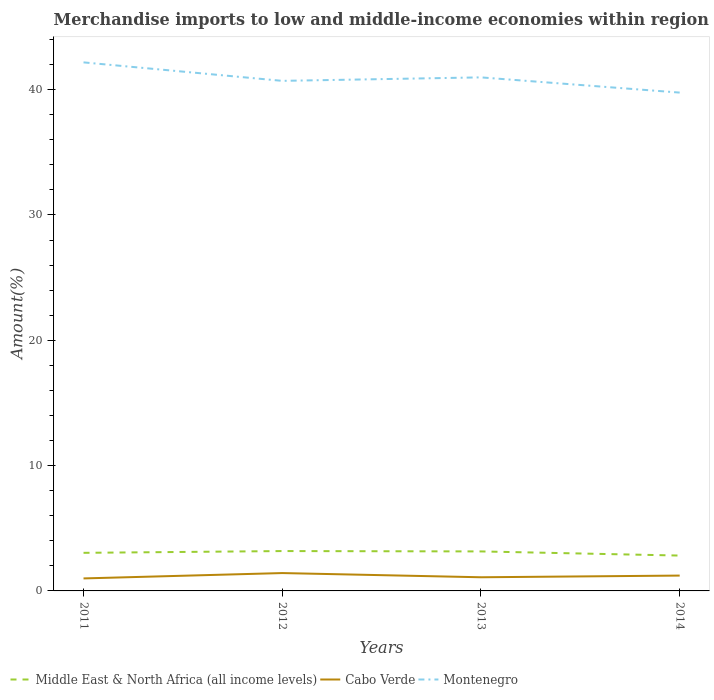Does the line corresponding to Middle East & North Africa (all income levels) intersect with the line corresponding to Montenegro?
Provide a short and direct response. No. Is the number of lines equal to the number of legend labels?
Your answer should be compact. Yes. Across all years, what is the maximum percentage of amount earned from merchandise imports in Cabo Verde?
Your answer should be compact. 1. In which year was the percentage of amount earned from merchandise imports in Montenegro maximum?
Provide a short and direct response. 2014. What is the total percentage of amount earned from merchandise imports in Montenegro in the graph?
Your answer should be compact. 1.47. What is the difference between the highest and the second highest percentage of amount earned from merchandise imports in Cabo Verde?
Offer a terse response. 0.43. How many lines are there?
Give a very brief answer. 3. How many years are there in the graph?
Make the answer very short. 4. Are the values on the major ticks of Y-axis written in scientific E-notation?
Make the answer very short. No. Does the graph contain any zero values?
Ensure brevity in your answer.  No. How many legend labels are there?
Give a very brief answer. 3. What is the title of the graph?
Offer a terse response. Merchandise imports to low and middle-income economies within region. Does "Barbados" appear as one of the legend labels in the graph?
Your answer should be compact. No. What is the label or title of the X-axis?
Provide a short and direct response. Years. What is the label or title of the Y-axis?
Provide a short and direct response. Amount(%). What is the Amount(%) in Middle East & North Africa (all income levels) in 2011?
Ensure brevity in your answer.  3.04. What is the Amount(%) in Cabo Verde in 2011?
Provide a succinct answer. 1. What is the Amount(%) in Montenegro in 2011?
Make the answer very short. 42.17. What is the Amount(%) of Middle East & North Africa (all income levels) in 2012?
Give a very brief answer. 3.18. What is the Amount(%) of Cabo Verde in 2012?
Make the answer very short. 1.43. What is the Amount(%) in Montenegro in 2012?
Your answer should be very brief. 40.7. What is the Amount(%) of Middle East & North Africa (all income levels) in 2013?
Your answer should be compact. 3.15. What is the Amount(%) of Cabo Verde in 2013?
Keep it short and to the point. 1.09. What is the Amount(%) of Montenegro in 2013?
Your answer should be compact. 40.98. What is the Amount(%) in Middle East & North Africa (all income levels) in 2014?
Your response must be concise. 2.82. What is the Amount(%) of Cabo Verde in 2014?
Provide a short and direct response. 1.22. What is the Amount(%) of Montenegro in 2014?
Your answer should be compact. 39.76. Across all years, what is the maximum Amount(%) of Middle East & North Africa (all income levels)?
Make the answer very short. 3.18. Across all years, what is the maximum Amount(%) of Cabo Verde?
Ensure brevity in your answer.  1.43. Across all years, what is the maximum Amount(%) in Montenegro?
Your answer should be compact. 42.17. Across all years, what is the minimum Amount(%) of Middle East & North Africa (all income levels)?
Make the answer very short. 2.82. Across all years, what is the minimum Amount(%) of Cabo Verde?
Your answer should be compact. 1. Across all years, what is the minimum Amount(%) of Montenegro?
Make the answer very short. 39.76. What is the total Amount(%) in Middle East & North Africa (all income levels) in the graph?
Provide a succinct answer. 12.19. What is the total Amount(%) of Cabo Verde in the graph?
Keep it short and to the point. 4.74. What is the total Amount(%) in Montenegro in the graph?
Provide a succinct answer. 163.61. What is the difference between the Amount(%) of Middle East & North Africa (all income levels) in 2011 and that in 2012?
Your answer should be very brief. -0.14. What is the difference between the Amount(%) of Cabo Verde in 2011 and that in 2012?
Provide a short and direct response. -0.43. What is the difference between the Amount(%) in Montenegro in 2011 and that in 2012?
Your response must be concise. 1.47. What is the difference between the Amount(%) in Middle East & North Africa (all income levels) in 2011 and that in 2013?
Offer a very short reply. -0.11. What is the difference between the Amount(%) in Cabo Verde in 2011 and that in 2013?
Your response must be concise. -0.09. What is the difference between the Amount(%) in Montenegro in 2011 and that in 2013?
Make the answer very short. 1.2. What is the difference between the Amount(%) of Middle East & North Africa (all income levels) in 2011 and that in 2014?
Your answer should be very brief. 0.22. What is the difference between the Amount(%) of Cabo Verde in 2011 and that in 2014?
Provide a succinct answer. -0.23. What is the difference between the Amount(%) of Montenegro in 2011 and that in 2014?
Ensure brevity in your answer.  2.41. What is the difference between the Amount(%) in Middle East & North Africa (all income levels) in 2012 and that in 2013?
Ensure brevity in your answer.  0.03. What is the difference between the Amount(%) of Cabo Verde in 2012 and that in 2013?
Keep it short and to the point. 0.34. What is the difference between the Amount(%) in Montenegro in 2012 and that in 2013?
Offer a terse response. -0.28. What is the difference between the Amount(%) in Middle East & North Africa (all income levels) in 2012 and that in 2014?
Provide a short and direct response. 0.36. What is the difference between the Amount(%) in Cabo Verde in 2012 and that in 2014?
Your response must be concise. 0.2. What is the difference between the Amount(%) in Montenegro in 2012 and that in 2014?
Keep it short and to the point. 0.94. What is the difference between the Amount(%) in Middle East & North Africa (all income levels) in 2013 and that in 2014?
Provide a short and direct response. 0.33. What is the difference between the Amount(%) of Cabo Verde in 2013 and that in 2014?
Your answer should be very brief. -0.13. What is the difference between the Amount(%) of Montenegro in 2013 and that in 2014?
Your answer should be compact. 1.21. What is the difference between the Amount(%) in Middle East & North Africa (all income levels) in 2011 and the Amount(%) in Cabo Verde in 2012?
Give a very brief answer. 1.61. What is the difference between the Amount(%) in Middle East & North Africa (all income levels) in 2011 and the Amount(%) in Montenegro in 2012?
Keep it short and to the point. -37.66. What is the difference between the Amount(%) of Cabo Verde in 2011 and the Amount(%) of Montenegro in 2012?
Provide a short and direct response. -39.7. What is the difference between the Amount(%) of Middle East & North Africa (all income levels) in 2011 and the Amount(%) of Cabo Verde in 2013?
Give a very brief answer. 1.95. What is the difference between the Amount(%) in Middle East & North Africa (all income levels) in 2011 and the Amount(%) in Montenegro in 2013?
Make the answer very short. -37.94. What is the difference between the Amount(%) in Cabo Verde in 2011 and the Amount(%) in Montenegro in 2013?
Your answer should be compact. -39.98. What is the difference between the Amount(%) in Middle East & North Africa (all income levels) in 2011 and the Amount(%) in Cabo Verde in 2014?
Ensure brevity in your answer.  1.81. What is the difference between the Amount(%) in Middle East & North Africa (all income levels) in 2011 and the Amount(%) in Montenegro in 2014?
Provide a short and direct response. -36.72. What is the difference between the Amount(%) of Cabo Verde in 2011 and the Amount(%) of Montenegro in 2014?
Give a very brief answer. -38.76. What is the difference between the Amount(%) of Middle East & North Africa (all income levels) in 2012 and the Amount(%) of Cabo Verde in 2013?
Provide a succinct answer. 2.09. What is the difference between the Amount(%) of Middle East & North Africa (all income levels) in 2012 and the Amount(%) of Montenegro in 2013?
Offer a terse response. -37.8. What is the difference between the Amount(%) of Cabo Verde in 2012 and the Amount(%) of Montenegro in 2013?
Give a very brief answer. -39.55. What is the difference between the Amount(%) of Middle East & North Africa (all income levels) in 2012 and the Amount(%) of Cabo Verde in 2014?
Your answer should be very brief. 1.96. What is the difference between the Amount(%) of Middle East & North Africa (all income levels) in 2012 and the Amount(%) of Montenegro in 2014?
Your answer should be very brief. -36.58. What is the difference between the Amount(%) in Cabo Verde in 2012 and the Amount(%) in Montenegro in 2014?
Your answer should be very brief. -38.34. What is the difference between the Amount(%) in Middle East & North Africa (all income levels) in 2013 and the Amount(%) in Cabo Verde in 2014?
Provide a succinct answer. 1.93. What is the difference between the Amount(%) of Middle East & North Africa (all income levels) in 2013 and the Amount(%) of Montenegro in 2014?
Provide a succinct answer. -36.61. What is the difference between the Amount(%) in Cabo Verde in 2013 and the Amount(%) in Montenegro in 2014?
Offer a terse response. -38.67. What is the average Amount(%) in Middle East & North Africa (all income levels) per year?
Provide a short and direct response. 3.05. What is the average Amount(%) in Cabo Verde per year?
Your answer should be compact. 1.18. What is the average Amount(%) in Montenegro per year?
Provide a succinct answer. 40.9. In the year 2011, what is the difference between the Amount(%) of Middle East & North Africa (all income levels) and Amount(%) of Cabo Verde?
Give a very brief answer. 2.04. In the year 2011, what is the difference between the Amount(%) of Middle East & North Africa (all income levels) and Amount(%) of Montenegro?
Make the answer very short. -39.13. In the year 2011, what is the difference between the Amount(%) of Cabo Verde and Amount(%) of Montenegro?
Ensure brevity in your answer.  -41.18. In the year 2012, what is the difference between the Amount(%) of Middle East & North Africa (all income levels) and Amount(%) of Cabo Verde?
Make the answer very short. 1.76. In the year 2012, what is the difference between the Amount(%) in Middle East & North Africa (all income levels) and Amount(%) in Montenegro?
Keep it short and to the point. -37.52. In the year 2012, what is the difference between the Amount(%) of Cabo Verde and Amount(%) of Montenegro?
Provide a succinct answer. -39.27. In the year 2013, what is the difference between the Amount(%) of Middle East & North Africa (all income levels) and Amount(%) of Cabo Verde?
Ensure brevity in your answer.  2.06. In the year 2013, what is the difference between the Amount(%) in Middle East & North Africa (all income levels) and Amount(%) in Montenegro?
Make the answer very short. -37.82. In the year 2013, what is the difference between the Amount(%) in Cabo Verde and Amount(%) in Montenegro?
Offer a terse response. -39.89. In the year 2014, what is the difference between the Amount(%) in Middle East & North Africa (all income levels) and Amount(%) in Cabo Verde?
Your answer should be compact. 1.6. In the year 2014, what is the difference between the Amount(%) of Middle East & North Africa (all income levels) and Amount(%) of Montenegro?
Make the answer very short. -36.94. In the year 2014, what is the difference between the Amount(%) of Cabo Verde and Amount(%) of Montenegro?
Keep it short and to the point. -38.54. What is the ratio of the Amount(%) of Middle East & North Africa (all income levels) in 2011 to that in 2012?
Provide a short and direct response. 0.96. What is the ratio of the Amount(%) of Cabo Verde in 2011 to that in 2012?
Your response must be concise. 0.7. What is the ratio of the Amount(%) of Montenegro in 2011 to that in 2012?
Keep it short and to the point. 1.04. What is the ratio of the Amount(%) in Cabo Verde in 2011 to that in 2013?
Provide a short and direct response. 0.92. What is the ratio of the Amount(%) in Montenegro in 2011 to that in 2013?
Ensure brevity in your answer.  1.03. What is the ratio of the Amount(%) in Middle East & North Africa (all income levels) in 2011 to that in 2014?
Keep it short and to the point. 1.08. What is the ratio of the Amount(%) of Cabo Verde in 2011 to that in 2014?
Give a very brief answer. 0.81. What is the ratio of the Amount(%) in Montenegro in 2011 to that in 2014?
Provide a short and direct response. 1.06. What is the ratio of the Amount(%) of Middle East & North Africa (all income levels) in 2012 to that in 2013?
Your answer should be very brief. 1.01. What is the ratio of the Amount(%) in Cabo Verde in 2012 to that in 2013?
Provide a succinct answer. 1.31. What is the ratio of the Amount(%) of Montenegro in 2012 to that in 2013?
Offer a very short reply. 0.99. What is the ratio of the Amount(%) of Middle East & North Africa (all income levels) in 2012 to that in 2014?
Ensure brevity in your answer.  1.13. What is the ratio of the Amount(%) in Cabo Verde in 2012 to that in 2014?
Your answer should be compact. 1.16. What is the ratio of the Amount(%) in Montenegro in 2012 to that in 2014?
Your answer should be compact. 1.02. What is the ratio of the Amount(%) in Middle East & North Africa (all income levels) in 2013 to that in 2014?
Your answer should be very brief. 1.12. What is the ratio of the Amount(%) in Cabo Verde in 2013 to that in 2014?
Your answer should be compact. 0.89. What is the ratio of the Amount(%) in Montenegro in 2013 to that in 2014?
Provide a succinct answer. 1.03. What is the difference between the highest and the second highest Amount(%) of Middle East & North Africa (all income levels)?
Your answer should be compact. 0.03. What is the difference between the highest and the second highest Amount(%) of Cabo Verde?
Your answer should be very brief. 0.2. What is the difference between the highest and the second highest Amount(%) of Montenegro?
Offer a terse response. 1.2. What is the difference between the highest and the lowest Amount(%) of Middle East & North Africa (all income levels)?
Give a very brief answer. 0.36. What is the difference between the highest and the lowest Amount(%) of Cabo Verde?
Your answer should be very brief. 0.43. What is the difference between the highest and the lowest Amount(%) in Montenegro?
Give a very brief answer. 2.41. 